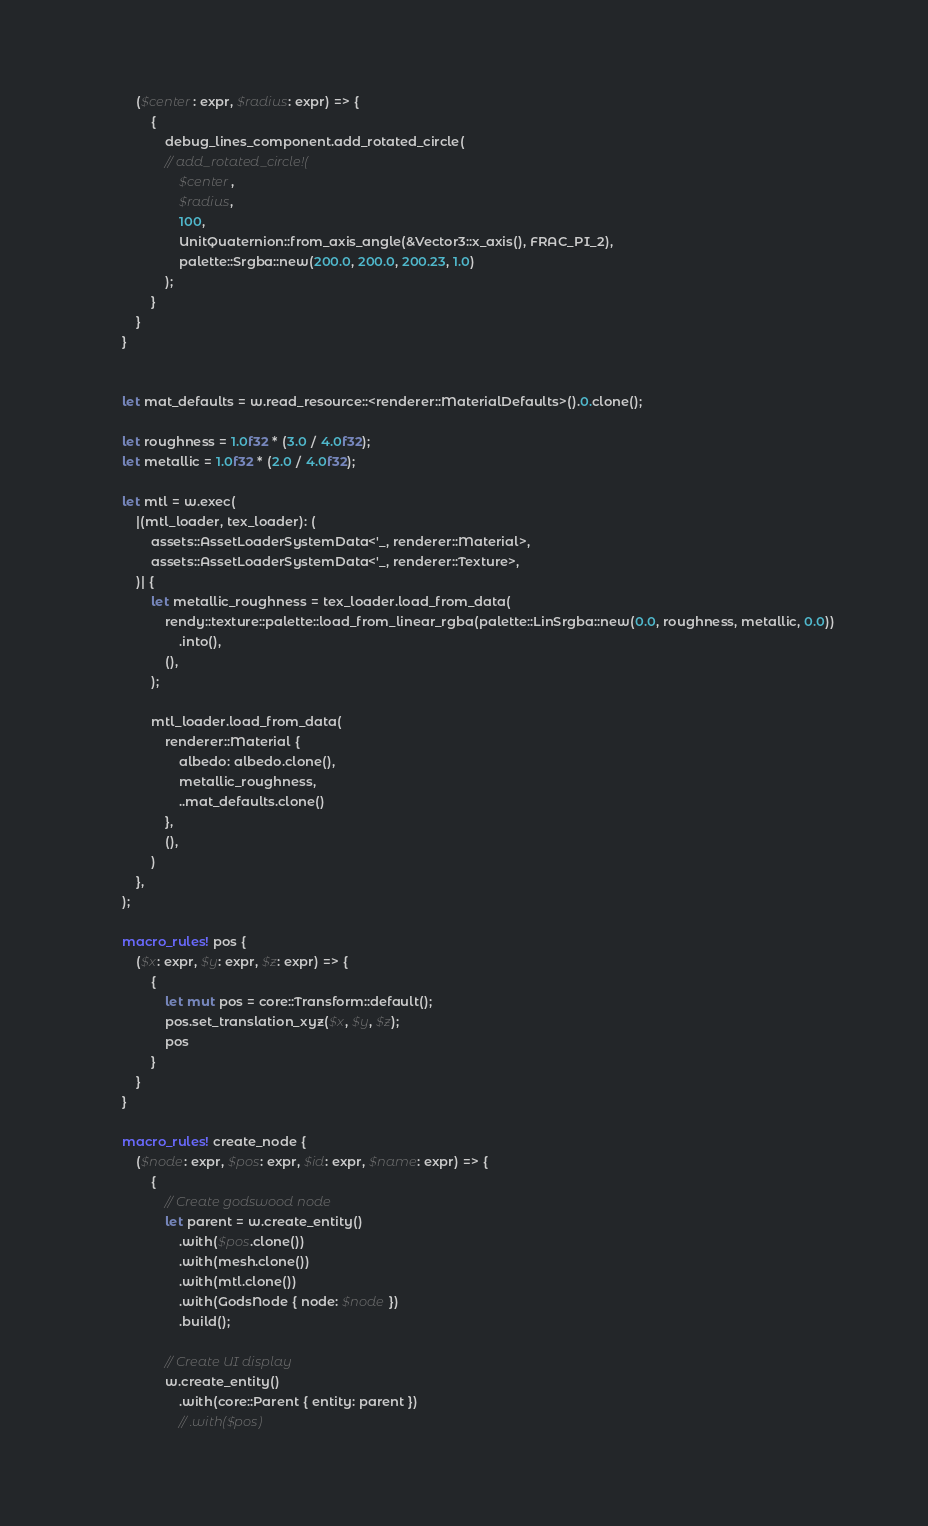Convert code to text. <code><loc_0><loc_0><loc_500><loc_500><_Rust_>            ($center: expr, $radius: expr) => {
                {
                    debug_lines_component.add_rotated_circle(
                    // add_rotated_circle!(
                        $center,
                        $radius,
                        100,
                        UnitQuaternion::from_axis_angle(&Vector3::x_axis(), FRAC_PI_2),
                        palette::Srgba::new(200.0, 200.0, 200.23, 1.0)
                    );
                }
            }
        }


        let mat_defaults = w.read_resource::<renderer::MaterialDefaults>().0.clone();

        let roughness = 1.0f32 * (3.0 / 4.0f32);
        let metallic = 1.0f32 * (2.0 / 4.0f32);

        let mtl = w.exec(
            |(mtl_loader, tex_loader): (
                assets::AssetLoaderSystemData<'_, renderer::Material>,
                assets::AssetLoaderSystemData<'_, renderer::Texture>,
            )| {
                let metallic_roughness = tex_loader.load_from_data(
                    rendy::texture::palette::load_from_linear_rgba(palette::LinSrgba::new(0.0, roughness, metallic, 0.0))
                        .into(),
                    (),
                );

                mtl_loader.load_from_data(
                    renderer::Material {
                        albedo: albedo.clone(),
                        metallic_roughness,
                        ..mat_defaults.clone()
                    },
                    (),
                )
            },
        );

        macro_rules! pos {
            ($x: expr, $y: expr, $z: expr) => {
                {
                    let mut pos = core::Transform::default();
                    pos.set_translation_xyz($x, $y, $z);
                    pos
                }
            }
        }

        macro_rules! create_node {
            ($node: expr, $pos: expr, $id: expr, $name: expr) => {
                {
                    // Create godswood node
                    let parent = w.create_entity()
                        .with($pos.clone())
                        .with(mesh.clone())
                        .with(mtl.clone())
                        .with(GodsNode { node: $node })
                        .build();

                    // Create UI display
                    w.create_entity()
                        .with(core::Parent { entity: parent })
                        // .with($pos)</code> 